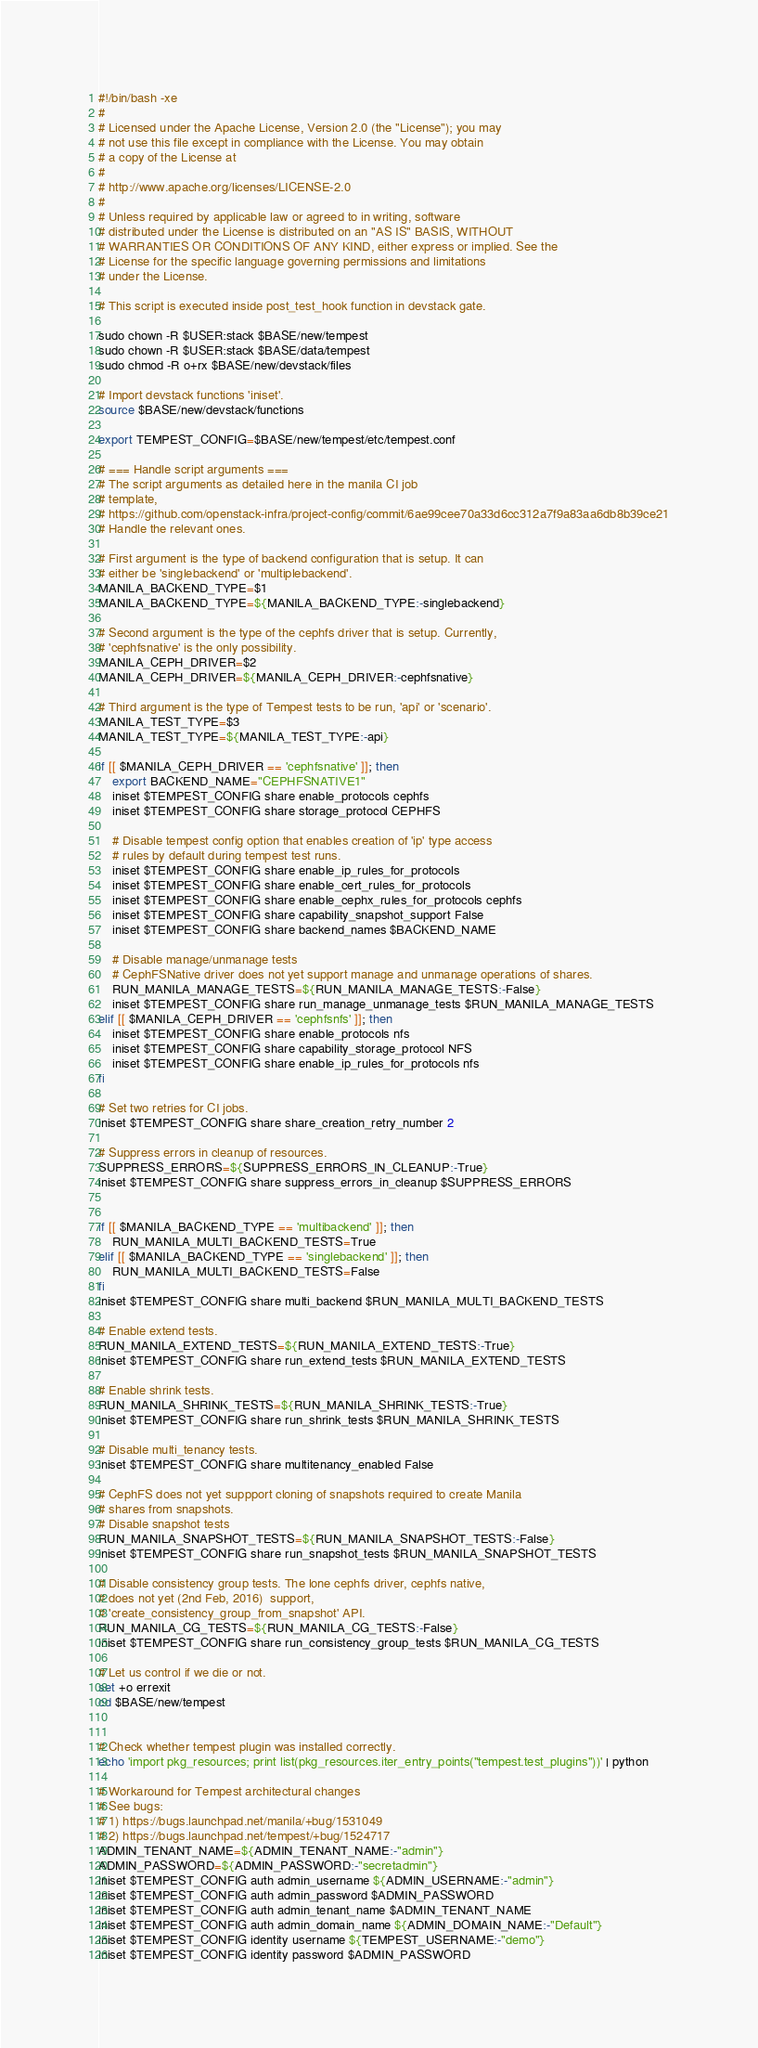<code> <loc_0><loc_0><loc_500><loc_500><_Bash_>#!/bin/bash -xe
#
# Licensed under the Apache License, Version 2.0 (the "License"); you may
# not use this file except in compliance with the License. You may obtain
# a copy of the License at
#
# http://www.apache.org/licenses/LICENSE-2.0
#
# Unless required by applicable law or agreed to in writing, software
# distributed under the License is distributed on an "AS IS" BASIS, WITHOUT
# WARRANTIES OR CONDITIONS OF ANY KIND, either express or implied. See the
# License for the specific language governing permissions and limitations
# under the License.

# This script is executed inside post_test_hook function in devstack gate.

sudo chown -R $USER:stack $BASE/new/tempest
sudo chown -R $USER:stack $BASE/data/tempest
sudo chmod -R o+rx $BASE/new/devstack/files

# Import devstack functions 'iniset'.
source $BASE/new/devstack/functions

export TEMPEST_CONFIG=$BASE/new/tempest/etc/tempest.conf

# === Handle script arguments ===
# The script arguments as detailed here in the manila CI job
# template,
# https://github.com/openstack-infra/project-config/commit/6ae99cee70a33d6cc312a7f9a83aa6db8b39ce21
# Handle the relevant ones.

# First argument is the type of backend configuration that is setup. It can
# either be 'singlebackend' or 'multiplebackend'.
MANILA_BACKEND_TYPE=$1
MANILA_BACKEND_TYPE=${MANILA_BACKEND_TYPE:-singlebackend}

# Second argument is the type of the cephfs driver that is setup. Currently,
# 'cephfsnative' is the only possibility.
MANILA_CEPH_DRIVER=$2
MANILA_CEPH_DRIVER=${MANILA_CEPH_DRIVER:-cephfsnative}

# Third argument is the type of Tempest tests to be run, 'api' or 'scenario'.
MANILA_TEST_TYPE=$3
MANILA_TEST_TYPE=${MANILA_TEST_TYPE:-api}

if [[ $MANILA_CEPH_DRIVER == 'cephfsnative' ]]; then
    export BACKEND_NAME="CEPHFSNATIVE1"
    iniset $TEMPEST_CONFIG share enable_protocols cephfs
    iniset $TEMPEST_CONFIG share storage_protocol CEPHFS

    # Disable tempest config option that enables creation of 'ip' type access
    # rules by default during tempest test runs.
    iniset $TEMPEST_CONFIG share enable_ip_rules_for_protocols
    iniset $TEMPEST_CONFIG share enable_cert_rules_for_protocols
    iniset $TEMPEST_CONFIG share enable_cephx_rules_for_protocols cephfs
    iniset $TEMPEST_CONFIG share capability_snapshot_support False
    iniset $TEMPEST_CONFIG share backend_names $BACKEND_NAME

    # Disable manage/unmanage tests
    # CephFSNative driver does not yet support manage and unmanage operations of shares.
    RUN_MANILA_MANAGE_TESTS=${RUN_MANILA_MANAGE_TESTS:-False}
    iniset $TEMPEST_CONFIG share run_manage_unmanage_tests $RUN_MANILA_MANAGE_TESTS
elif [[ $MANILA_CEPH_DRIVER == 'cephfsnfs' ]]; then
    iniset $TEMPEST_CONFIG share enable_protocols nfs
    iniset $TEMPEST_CONFIG share capability_storage_protocol NFS
    iniset $TEMPEST_CONFIG share enable_ip_rules_for_protocols nfs
fi

# Set two retries for CI jobs.
iniset $TEMPEST_CONFIG share share_creation_retry_number 2

# Suppress errors in cleanup of resources.
SUPPRESS_ERRORS=${SUPPRESS_ERRORS_IN_CLEANUP:-True}
iniset $TEMPEST_CONFIG share suppress_errors_in_cleanup $SUPPRESS_ERRORS


if [[ $MANILA_BACKEND_TYPE == 'multibackend' ]]; then
    RUN_MANILA_MULTI_BACKEND_TESTS=True
elif [[ $MANILA_BACKEND_TYPE == 'singlebackend' ]]; then
    RUN_MANILA_MULTI_BACKEND_TESTS=False
fi
iniset $TEMPEST_CONFIG share multi_backend $RUN_MANILA_MULTI_BACKEND_TESTS

# Enable extend tests.
RUN_MANILA_EXTEND_TESTS=${RUN_MANILA_EXTEND_TESTS:-True}
iniset $TEMPEST_CONFIG share run_extend_tests $RUN_MANILA_EXTEND_TESTS

# Enable shrink tests.
RUN_MANILA_SHRINK_TESTS=${RUN_MANILA_SHRINK_TESTS:-True}
iniset $TEMPEST_CONFIG share run_shrink_tests $RUN_MANILA_SHRINK_TESTS

# Disable multi_tenancy tests.
iniset $TEMPEST_CONFIG share multitenancy_enabled False

# CephFS does not yet suppport cloning of snapshots required to create Manila
# shares from snapshots.
# Disable snapshot tests
RUN_MANILA_SNAPSHOT_TESTS=${RUN_MANILA_SNAPSHOT_TESTS:-False}
iniset $TEMPEST_CONFIG share run_snapshot_tests $RUN_MANILA_SNAPSHOT_TESTS

# Disable consistency group tests. The lone cephfs driver, cephfs native,
# does not yet (2nd Feb, 2016)  support,
# 'create_consistency_group_from_snapshot' API.
RUN_MANILA_CG_TESTS=${RUN_MANILA_CG_TESTS:-False}
iniset $TEMPEST_CONFIG share run_consistency_group_tests $RUN_MANILA_CG_TESTS

# Let us control if we die or not.
set +o errexit
cd $BASE/new/tempest


# Check whether tempest plugin was installed correctly.
echo 'import pkg_resources; print list(pkg_resources.iter_entry_points("tempest.test_plugins"))' | python

# Workaround for Tempest architectural changes
# See bugs:
# 1) https://bugs.launchpad.net/manila/+bug/1531049
# 2) https://bugs.launchpad.net/tempest/+bug/1524717
ADMIN_TENANT_NAME=${ADMIN_TENANT_NAME:-"admin"}
ADMIN_PASSWORD=${ADMIN_PASSWORD:-"secretadmin"}
iniset $TEMPEST_CONFIG auth admin_username ${ADMIN_USERNAME:-"admin"}
iniset $TEMPEST_CONFIG auth admin_password $ADMIN_PASSWORD
iniset $TEMPEST_CONFIG auth admin_tenant_name $ADMIN_TENANT_NAME
iniset $TEMPEST_CONFIG auth admin_domain_name ${ADMIN_DOMAIN_NAME:-"Default"}
iniset $TEMPEST_CONFIG identity username ${TEMPEST_USERNAME:-"demo"}
iniset $TEMPEST_CONFIG identity password $ADMIN_PASSWORD</code> 